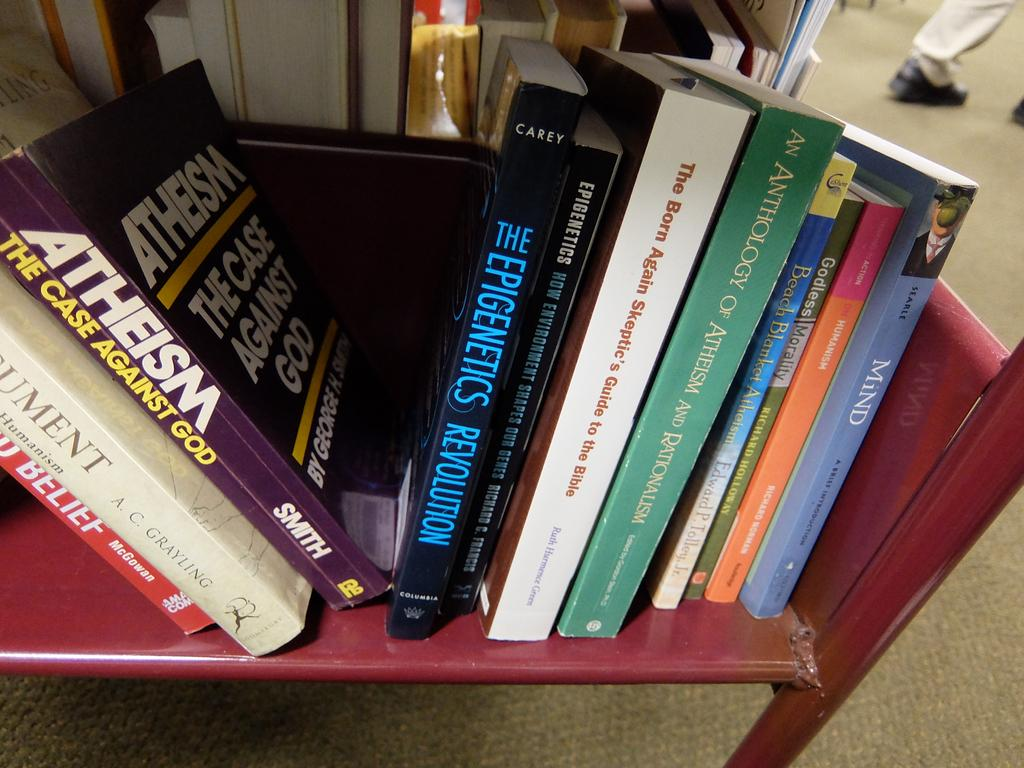<image>
Write a terse but informative summary of the picture. A stack of books about Athiesm sitting on a bookshelf. 